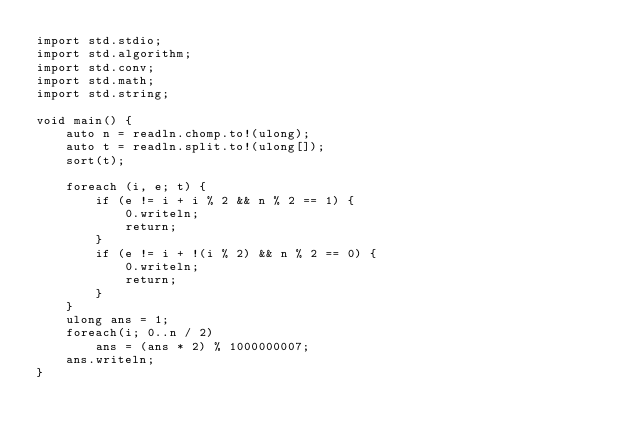Convert code to text. <code><loc_0><loc_0><loc_500><loc_500><_D_>import std.stdio;
import std.algorithm;
import std.conv;
import std.math;
import std.string;

void main() {
    auto n = readln.chomp.to!(ulong);
    auto t = readln.split.to!(ulong[]);
    sort(t);

    foreach (i, e; t) {
        if (e != i + i % 2 && n % 2 == 1) {
            0.writeln;
            return;
        }
        if (e != i + !(i % 2) && n % 2 == 0) {
            0.writeln;
            return;
        }
    }
    ulong ans = 1;
    foreach(i; 0..n / 2)
        ans = (ans * 2) % 1000000007;
    ans.writeln;
}
</code> 